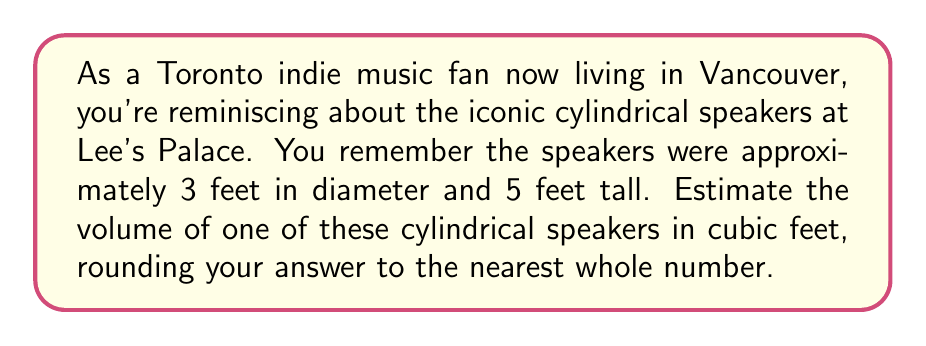Show me your answer to this math problem. To estimate the volume of a cylindrical speaker, we need to use the formula for the volume of a cylinder:

$$V = \pi r^2 h$$

Where:
$V$ = volume
$r$ = radius of the base
$h$ = height of the cylinder

Given:
- Diameter = 3 feet
- Height = 5 feet

Step 1: Calculate the radius
The radius is half the diameter:
$r = 3 \div 2 = 1.5$ feet

Step 2: Apply the volume formula
$$V = \pi (1.5\text{ ft})^2 (5\text{ ft})$$

Step 3: Simplify
$$V = \pi (2.25\text{ ft}^2) (5\text{ ft})$$
$$V = 11.25\pi\text{ ft}^3$$

Step 4: Calculate and round to the nearest whole number
$$V \approx 11.25 \times 3.14159 \approx 35.34\text{ ft}^3$$

Rounding to the nearest whole number: 35 cubic feet
Answer: 35 cubic feet 